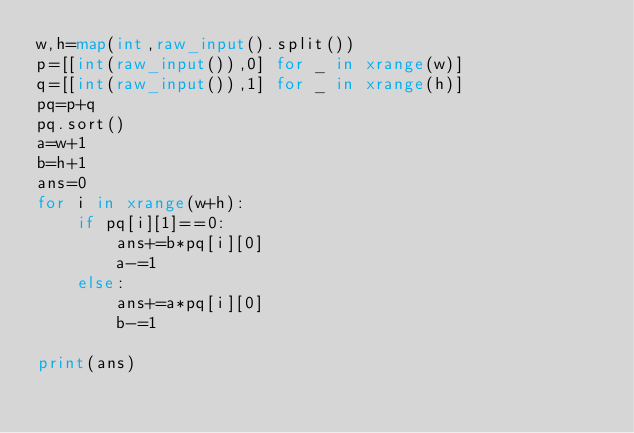<code> <loc_0><loc_0><loc_500><loc_500><_Python_>w,h=map(int,raw_input().split())
p=[[int(raw_input()),0] for _ in xrange(w)]
q=[[int(raw_input()),1] for _ in xrange(h)]
pq=p+q
pq.sort()
a=w+1
b=h+1
ans=0
for i in xrange(w+h):
    if pq[i][1]==0:
        ans+=b*pq[i][0]
        a-=1
    else:
        ans+=a*pq[i][0]
        b-=1

print(ans)</code> 